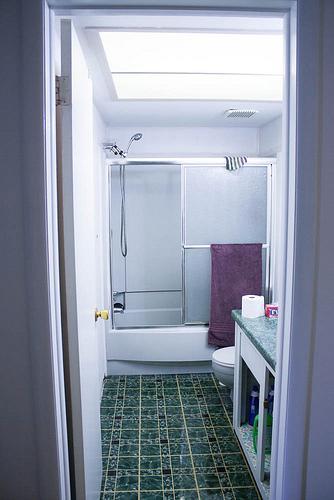How many toilets?
Give a very brief answer. 1. 